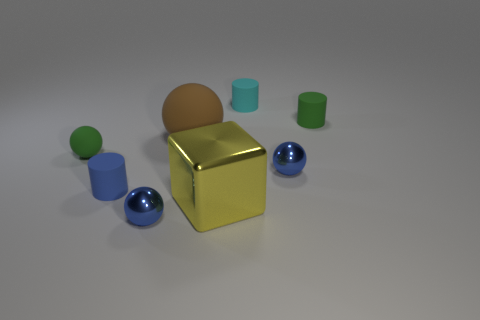Are there any patterns or repetitions visible in the arrangement of objects? There aren't any apparent patterns in the placement of the objects. The arrangement seems random without any discernible repetition or symmetry. What can you infer about the size of the room or space where the objects are? Based on the shadows and the perspective, it's difficult to ascertain the size of the room, but the smooth surface and diffuse lighting suggest an open, neutral space, possibly in a controlled setting like a studio. 